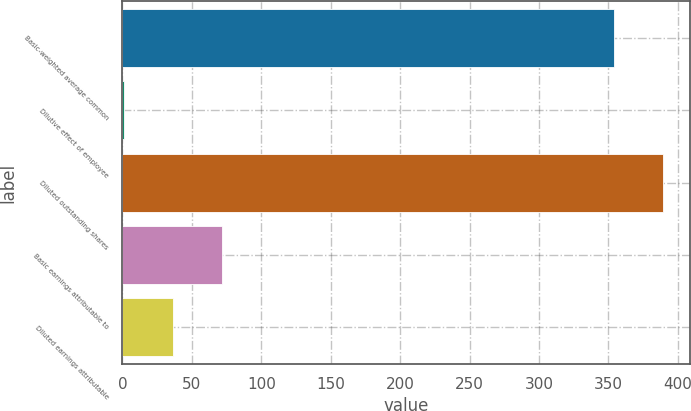<chart> <loc_0><loc_0><loc_500><loc_500><bar_chart><fcel>Basic-weighted average common<fcel>Dilutive effect of employee<fcel>Diluted outstanding shares<fcel>Basic earnings attributable to<fcel>Diluted earnings attributable<nl><fcel>354<fcel>1<fcel>389.4<fcel>71.8<fcel>36.4<nl></chart> 